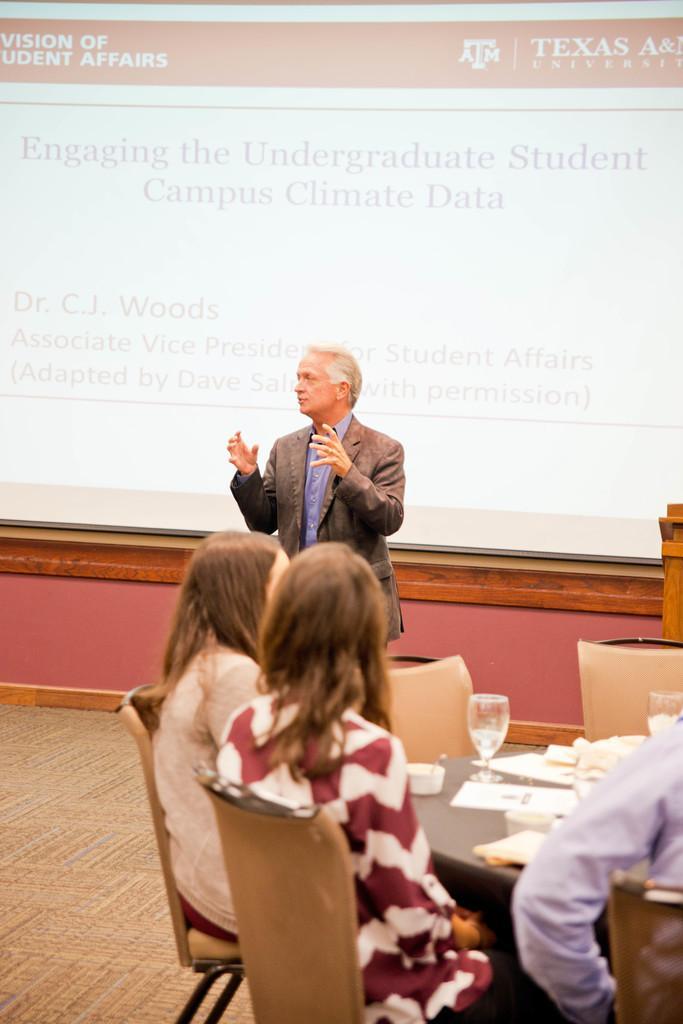In one or two sentences, can you explain what this image depicts? In this picture a man is speaking and there are few people sitting in front of them. They have a table in front of them, it has some tissues and wine glasses. 